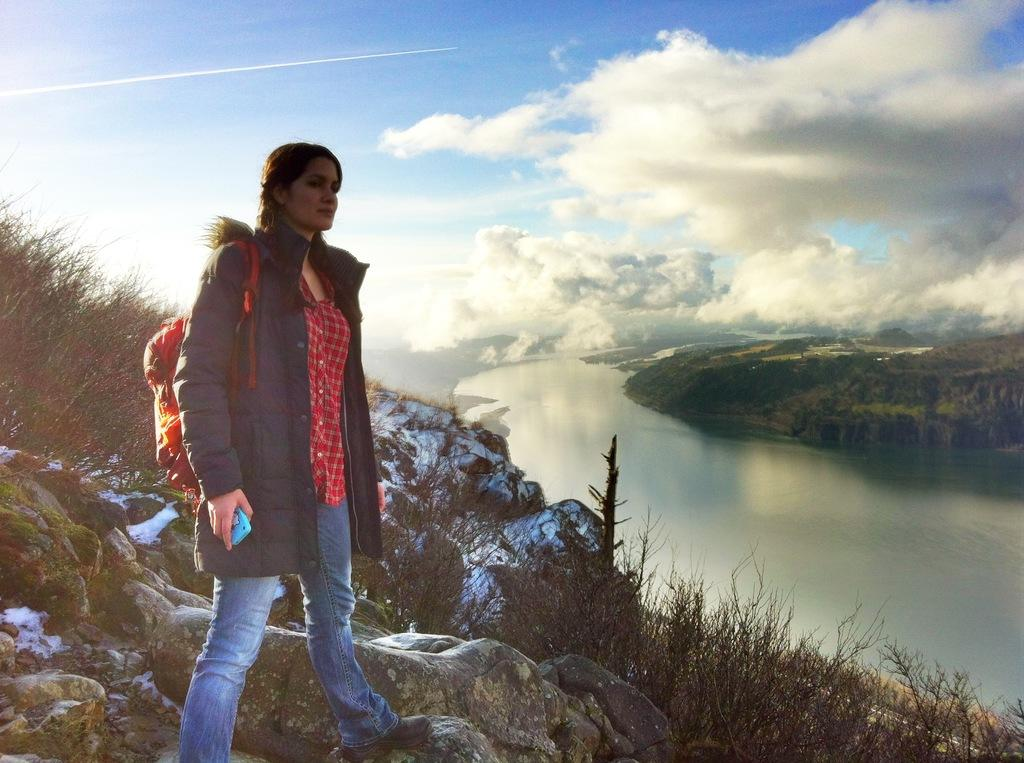What is the woman in the image doing? The woman is standing on a mountain in the image. What can be seen in the background of the image? Plants, water, trees, and the sky are visible in the background of the image. What is the weather like in the image? The image appears to have been taken on a sunny day. How many spiders are crawling on the floor in the image? There are no spiders or floors present in the image; it features a woman standing on a mountain with a background of plants, water, trees, and sky. 